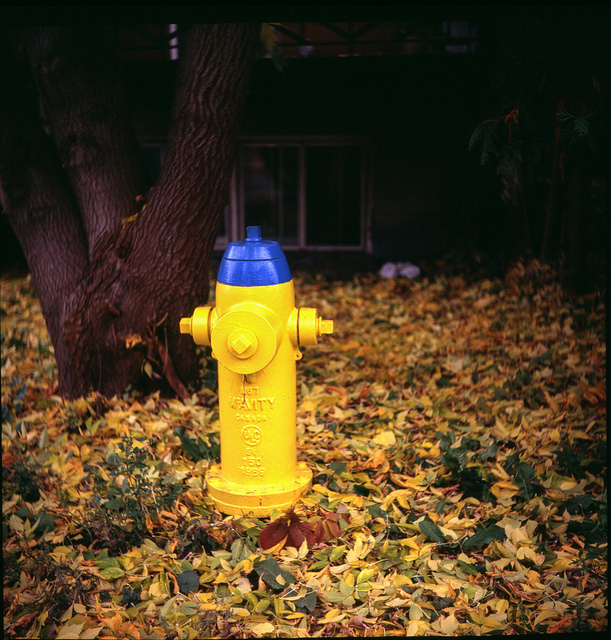<image>What size is the valve? It is unknown what size the valve is. It could be large, average, small, or a specific measurement such as 2 inches or 4 inches. What size is the valve? I am not sure what size the valve is. It can be either large, average, small or unknown. 